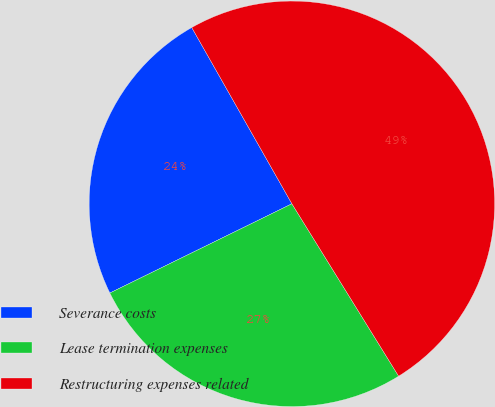<chart> <loc_0><loc_0><loc_500><loc_500><pie_chart><fcel>Severance costs<fcel>Lease termination expenses<fcel>Restructuring expenses related<nl><fcel>24.03%<fcel>26.57%<fcel>49.4%<nl></chart> 